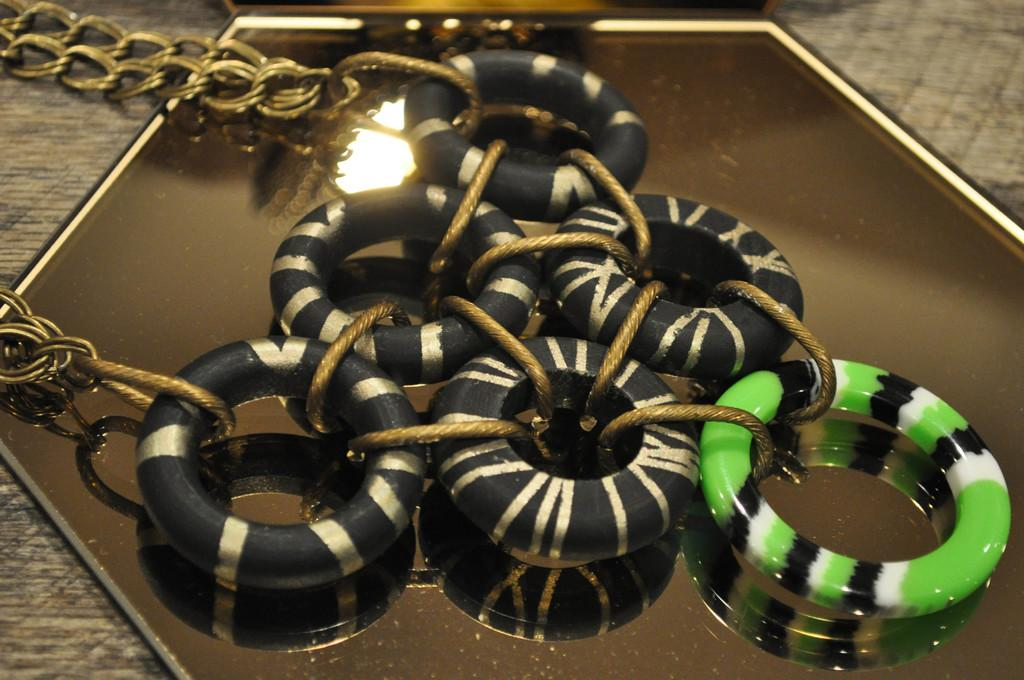What is attached to the mirror in the image? There are rings and a chain attached to the mirror in the image. How many worms can be seen crawling on the mirror in the image? There are no worms present in the image; it only features rings and a chain attached to the mirror. Is there a famous writer visible in the image? There is no writer present in the image; it only features a mirror with rings and a chain. 